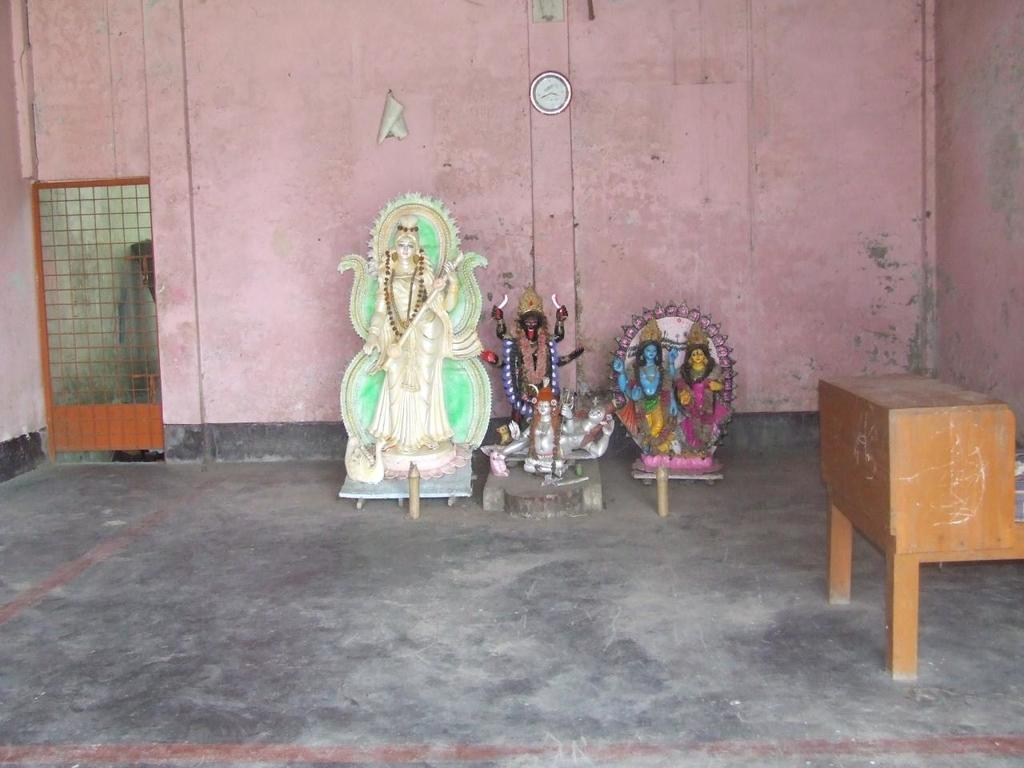What type of artifacts can be seen in the room? There are sculptures of gods in the room. What architectural feature is present in the room? The room has a gate. What piece of furniture is in the room? There is a table in the room. What timekeeping device is present in the room? There is a wall clock in the room. What color is the wall in the room? The wall is pink colored. What type of organization is responsible for the bun in the room? There is no bun present in the room, so it is not possible to determine which organization might be responsible. Can you tell me the total cost of the receipt on the table in the room? There is no receipt present on the table in the room, so it is not possible to determine the total cost. 